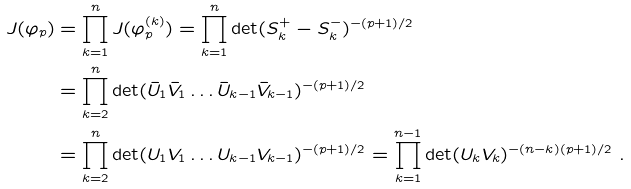<formula> <loc_0><loc_0><loc_500><loc_500>J ( \varphi _ { p } ) & = \prod _ { k = 1 } ^ { n } J ( \varphi _ { p } ^ { ( k ) } ) = \prod _ { k = 1 } ^ { n } \det ( S _ { k } ^ { + } - S _ { k } ^ { - } ) ^ { - ( p + 1 ) / 2 } \\ & = \prod _ { k = 2 } ^ { n } \det ( \bar { U } _ { 1 } \bar { V } _ { 1 } \dots \bar { U } _ { k - 1 } \bar { V } _ { k - 1 } ) ^ { - ( p + 1 ) / 2 } \\ & = \prod _ { k = 2 } ^ { n } \det ( U _ { 1 } V _ { 1 } \dots U _ { k - 1 } V _ { k - 1 } ) ^ { - ( p + 1 ) / 2 } = \prod _ { k = 1 } ^ { n - 1 } \det ( U _ { k } V _ { k } ) ^ { - ( n - k ) ( p + 1 ) / 2 } \ .</formula> 